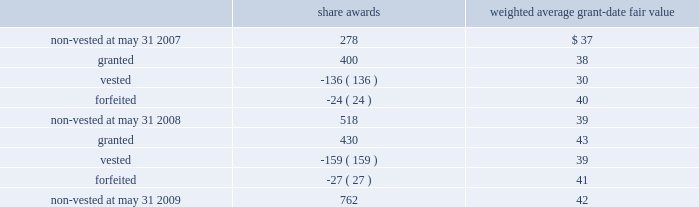Notes to consolidated financial statements 2014 ( continued ) the table summarizes the changes in non-vested restricted stock awards for the year ended may 31 , 2009 ( share awards in thousands ) : share awards weighted average grant-date fair value .
The weighted average grant-date fair value of share awards granted in the years ended may 31 , 2008 and 2007 was $ 38 and $ 45 , respectively .
The total fair value of share awards vested during the years ended may 31 , 2009 , 2008 and 2007 was $ 6.2 million , $ 4.1 million and $ 1.7 million , respectively .
We recognized compensation expense for restricted stock of $ 9.0 million , $ 5.7 million , and $ 2.7 million in the years ended may 31 , 2009 , 2008 and 2007 .
As of may 31 , 2009 , there was $ 23.5 million of total unrecognized compensation cost related to unvested restricted stock awards that is expected to be recognized over a weighted average period of 2.9 years .
Employee stock purchase plan we have an employee stock purchase plan under which the sale of 2.4 million shares of our common stock has been authorized .
Employees may designate up to the lesser of $ 25000 or 20% ( 20 % ) of their annual compensation for the purchase of stock .
The price for shares purchased under the plan is 85% ( 85 % ) of the market value on the last day of the quarterly purchase period .
As of may 31 , 2009 , 0.8 million shares had been issued under this plan , with 1.6 million shares reserved for future issuance .
The weighted average grant-date fair value of each designated share purchased under this plan was $ 6 , $ 6 and $ 8 in the years ended may 31 , 2009 , 2008 and 2007 , respectively .
These values represent the fair value of the 15% ( 15 % ) discount .
Note 12 2014segment information general information during fiscal 2009 , we began assessing our operating performance using a new segment structure .
We made this change as a result of our june 30 , 2008 acquisition of 51% ( 51 % ) of hsbc merchant services llp in the united kingdom , in addition to anticipated future international expansion .
Beginning with the quarter ended august 31 , 2008 , the reportable segments are defined as north america merchant services , international merchant services , and money transfer .
The following tables reflect these changes and such reportable segments for fiscal years 2009 , 2008 , and 2007. .
What is the total value of non-vested shares as of may 31 , 2008 , ( in millions ) ? 
Computations: ((518 * 39) / 1000)
Answer: 20.202. 